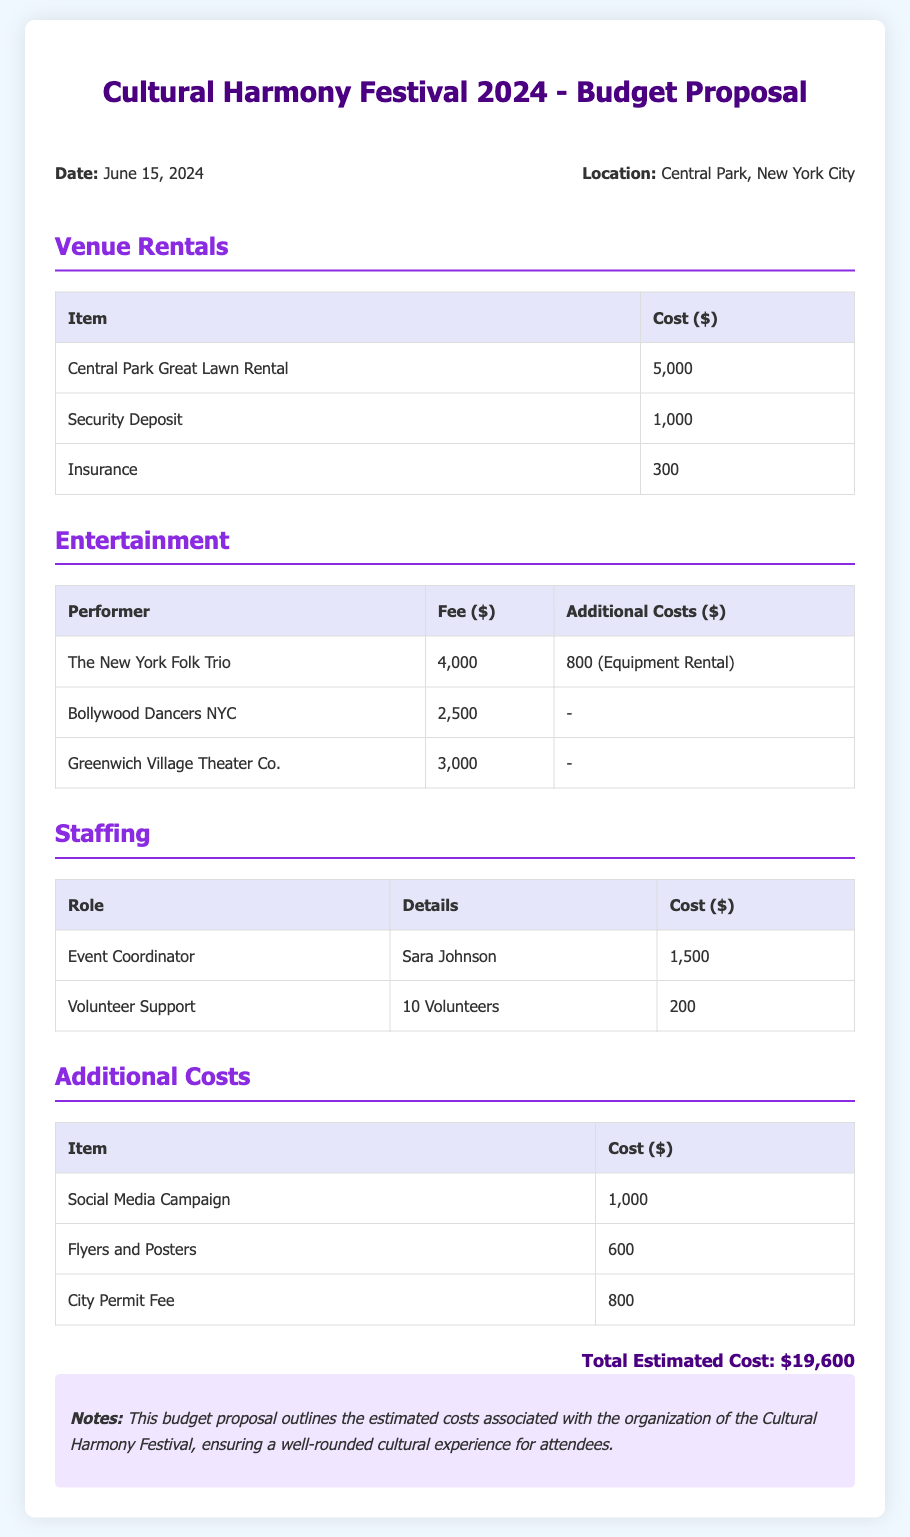what is the total estimated cost? The total estimated cost is given in the document as the sum of all expenses listed, which amounts to $19,600.
Answer: $19,600 what is the date of the festival? The date of the festival is mentioned at the beginning of the document as June 15, 2024.
Answer: June 15, 2024 how much is the rental cost for Central Park Great Lawn? The rental cost for Central Park Great Lawn is specifically listed in the Venue Rentals section of the document as $5,000.
Answer: $5,000 who is the Event Coordinator? The Event Coordinator's name is specified in the Staffing section as Sara Johnson.
Answer: Sara Johnson what is the fee for The New York Folk Trio? The fee for The New York Folk Trio is provided in the Entertainment section as $4,000.
Answer: $4,000 which item has an additional cost of 800 dollars? The item that has an additional cost of $800 is the Equipment Rental for The New York Folk Trio in the Entertainment section.
Answer: Equipment Rental how many volunteers are included in the budget? The budget includes 10 volunteers specified in the Staffing section of the document.
Answer: 10 Volunteers what are the total costs for additional costs? The additional costs total is calculated from all items listed under Additional Costs, which amount to $2,400.
Answer: $2,400 what is the city permit fee listed in the document? The city permit fee is mentioned in the Additional Costs section of the document as $800.
Answer: $800 